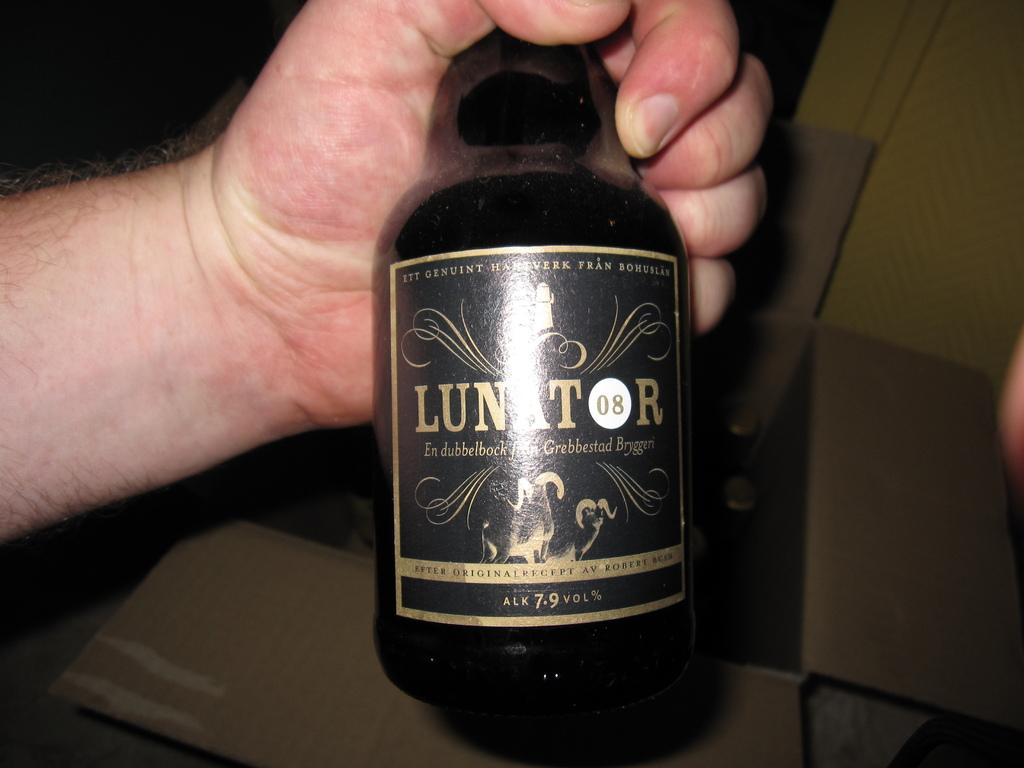<image>
Render a clear and concise summary of the photo. A hand holds a bottle of Lunator in front of a box. 